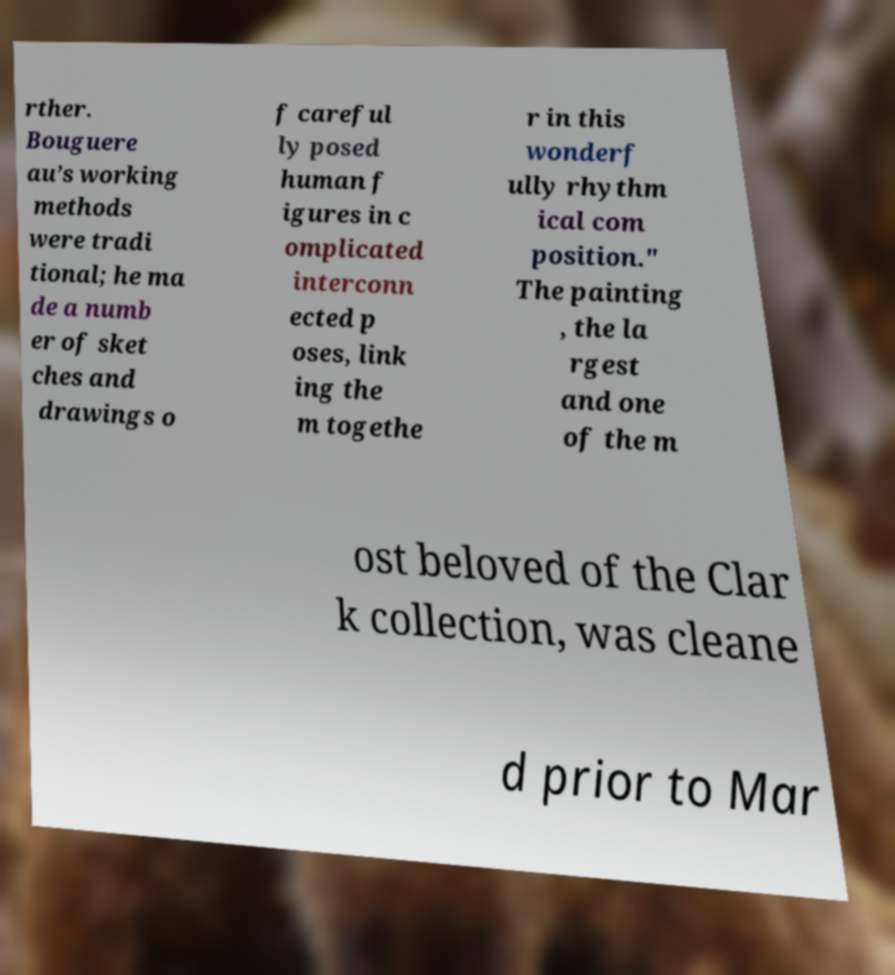Please identify and transcribe the text found in this image. rther. Bouguere au’s working methods were tradi tional; he ma de a numb er of sket ches and drawings o f careful ly posed human f igures in c omplicated interconn ected p oses, link ing the m togethe r in this wonderf ully rhythm ical com position." The painting , the la rgest and one of the m ost beloved of the Clar k collection, was cleane d prior to Mar 